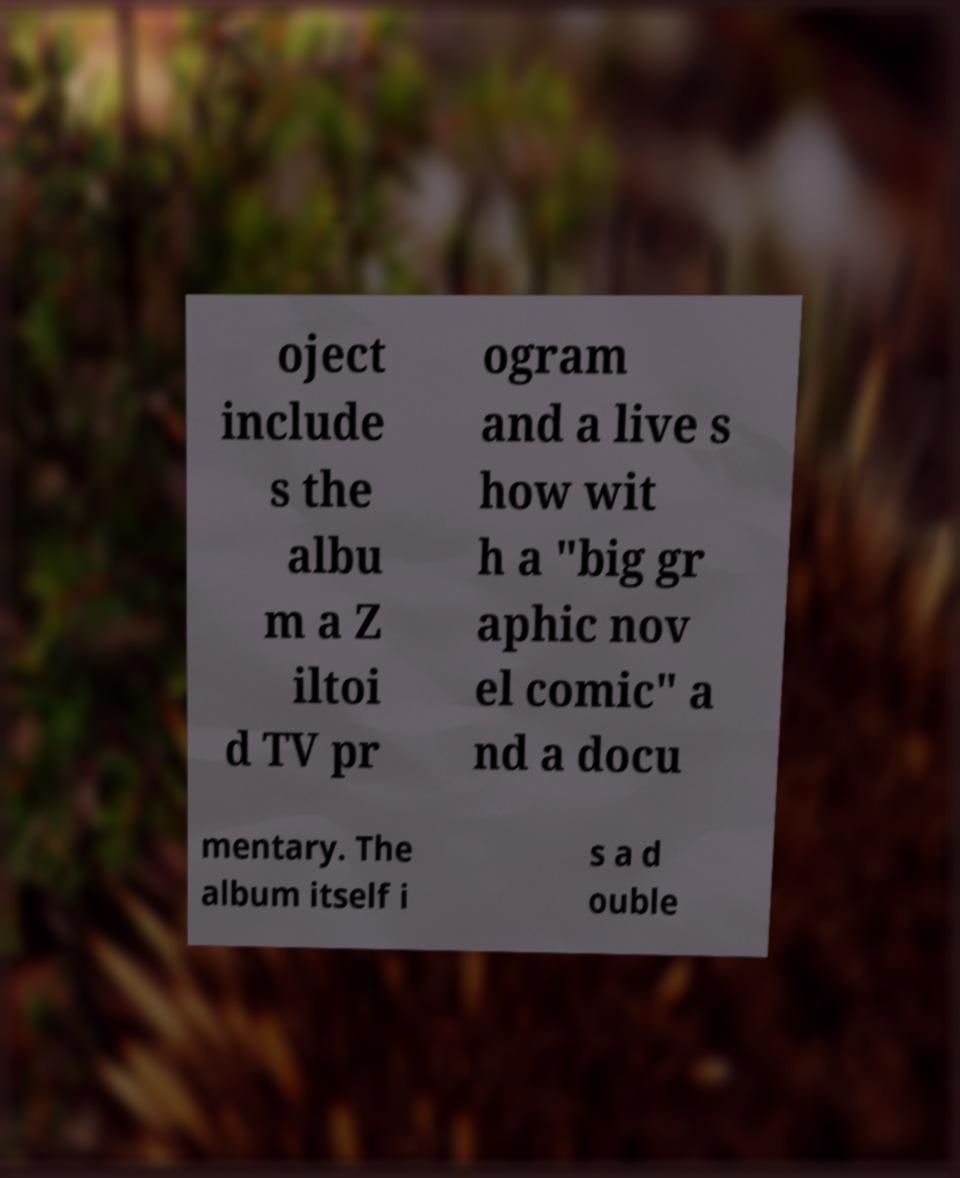For documentation purposes, I need the text within this image transcribed. Could you provide that? oject include s the albu m a Z iltoi d TV pr ogram and a live s how wit h a "big gr aphic nov el comic" a nd a docu mentary. The album itself i s a d ouble 